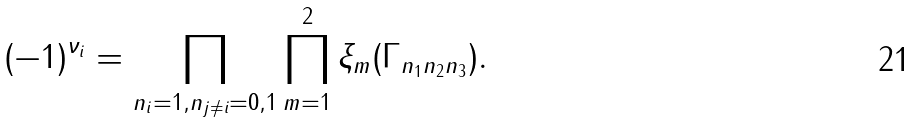<formula> <loc_0><loc_0><loc_500><loc_500>( - 1 ) ^ { \nu _ { i } } = \prod _ { n _ { i } = 1 , n _ { j \neq i } = 0 , 1 } \prod _ { m = 1 } ^ { 2 } \xi _ { m } ( \Gamma _ { n _ { 1 } n _ { 2 } n _ { 3 } } ) .</formula> 